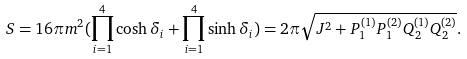<formula> <loc_0><loc_0><loc_500><loc_500>S = 1 6 \pi m ^ { 2 } ( \prod ^ { 4 } _ { i = 1 } \cosh \delta _ { i } + \prod ^ { 4 } _ { i = 1 } \sinh \delta _ { i } ) = 2 \pi \sqrt { J ^ { 2 } + P ^ { ( 1 ) } _ { 1 } P ^ { ( 2 ) } _ { 1 } Q ^ { ( 1 ) } _ { 2 } Q ^ { ( 2 ) } _ { 2 } } .</formula> 